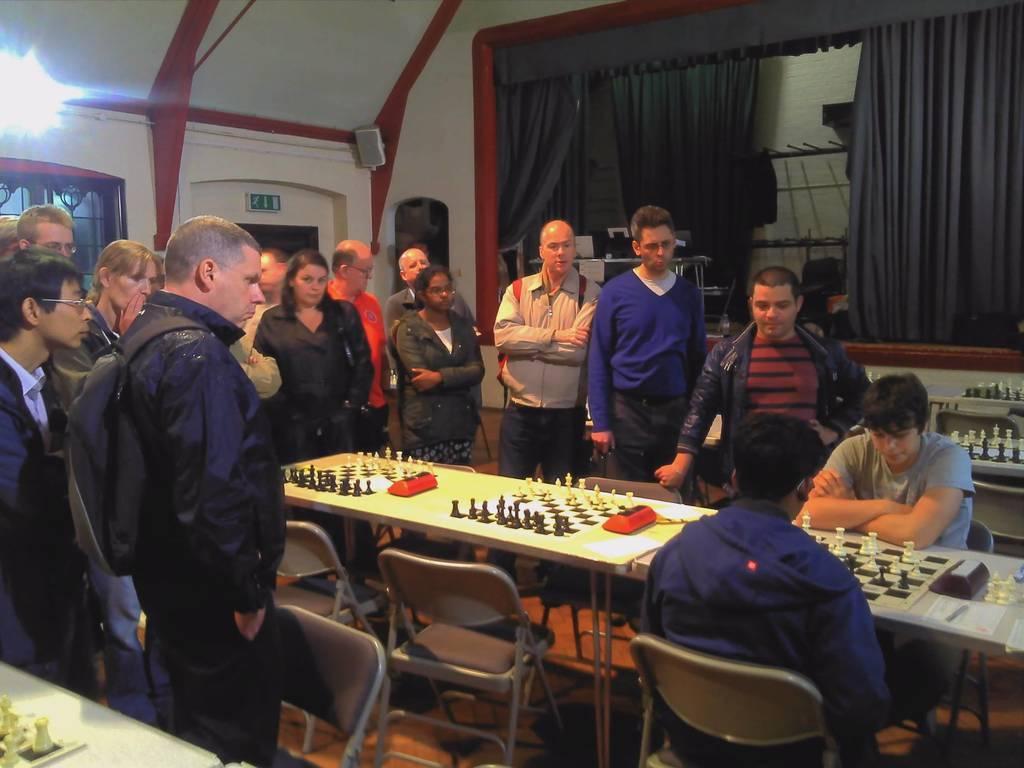Could you give a brief overview of what you see in this image? Here 2 persons are playing chess game. People over here are looking at their match. In the background there is a light,curtain. 